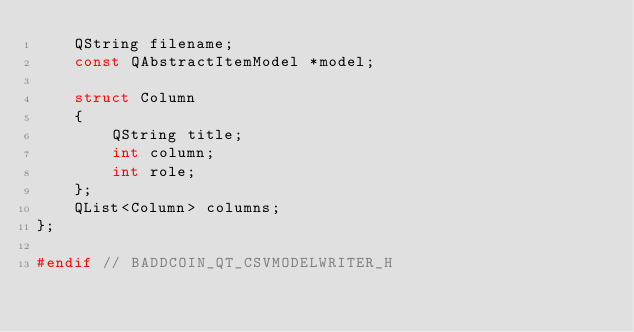<code> <loc_0><loc_0><loc_500><loc_500><_C_>    QString filename;
    const QAbstractItemModel *model;

    struct Column
    {
        QString title;
        int column;
        int role;
    };
    QList<Column> columns;
};

#endif // BADDCOIN_QT_CSVMODELWRITER_H
</code> 